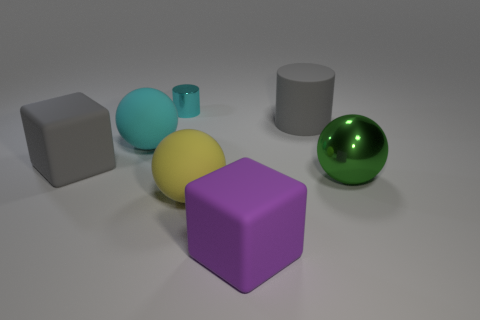How many things are either green things or matte cubes behind the green ball?
Your answer should be compact. 2. There is a cyan object that is to the right of the cyan rubber sphere; is its size the same as the gray rubber cylinder?
Keep it short and to the point. No. There is a sphere to the right of the large yellow ball; what material is it?
Provide a succinct answer. Metal. Are there the same number of tiny cylinders that are behind the cyan metal object and purple blocks right of the gray cube?
Give a very brief answer. No. The other thing that is the same shape as the purple object is what color?
Offer a terse response. Gray. Is there anything else that is the same color as the shiny ball?
Provide a short and direct response. No. What number of metallic things are large cyan objects or small cyan cylinders?
Your answer should be compact. 1. Is the number of large balls left of the big rubber cylinder greater than the number of shiny cylinders?
Provide a succinct answer. Yes. How many other objects are the same material as the green sphere?
Your response must be concise. 1. How many big things are metal objects or purple blocks?
Ensure brevity in your answer.  2. 